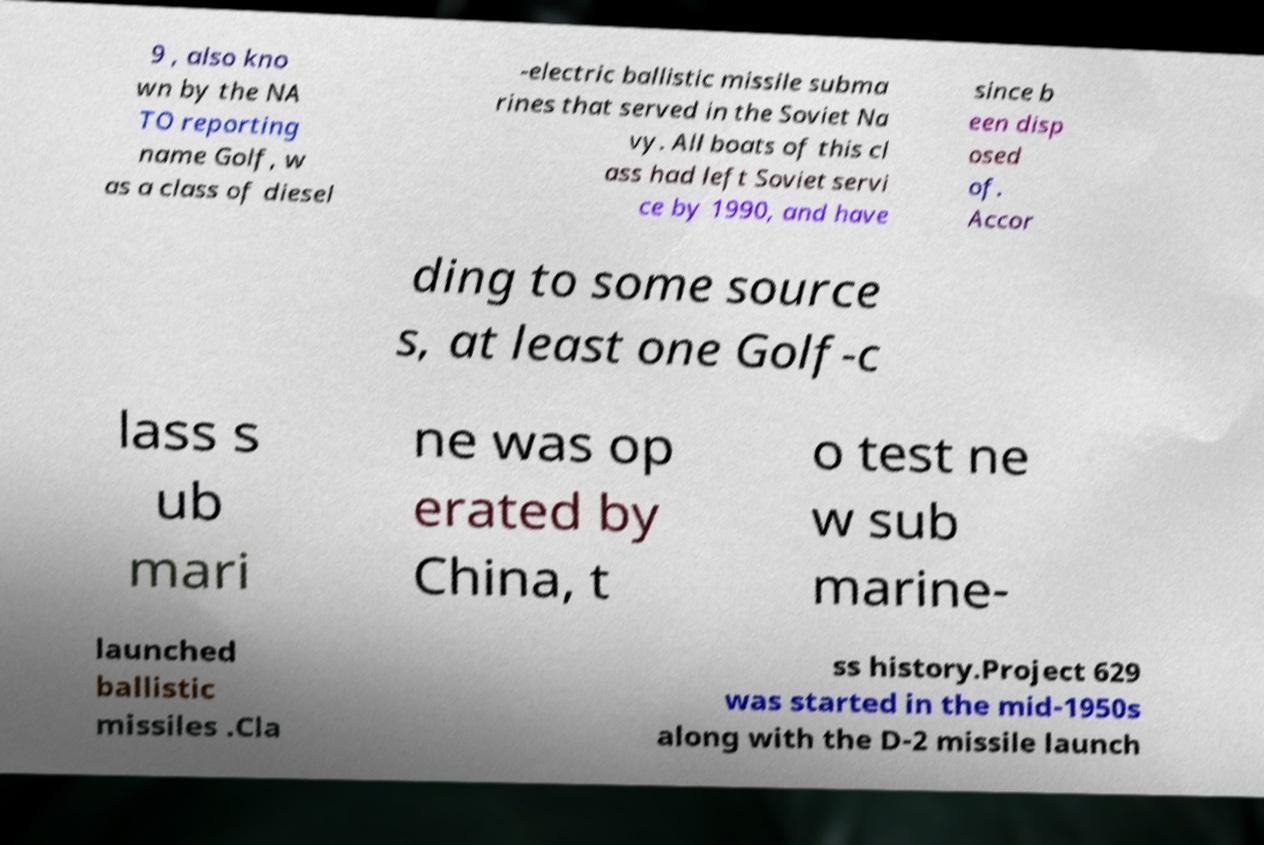Please read and relay the text visible in this image. What does it say? 9 , also kno wn by the NA TO reporting name Golf, w as a class of diesel -electric ballistic missile subma rines that served in the Soviet Na vy. All boats of this cl ass had left Soviet servi ce by 1990, and have since b een disp osed of. Accor ding to some source s, at least one Golf-c lass s ub mari ne was op erated by China, t o test ne w sub marine- launched ballistic missiles .Cla ss history.Project 629 was started in the mid-1950s along with the D-2 missile launch 